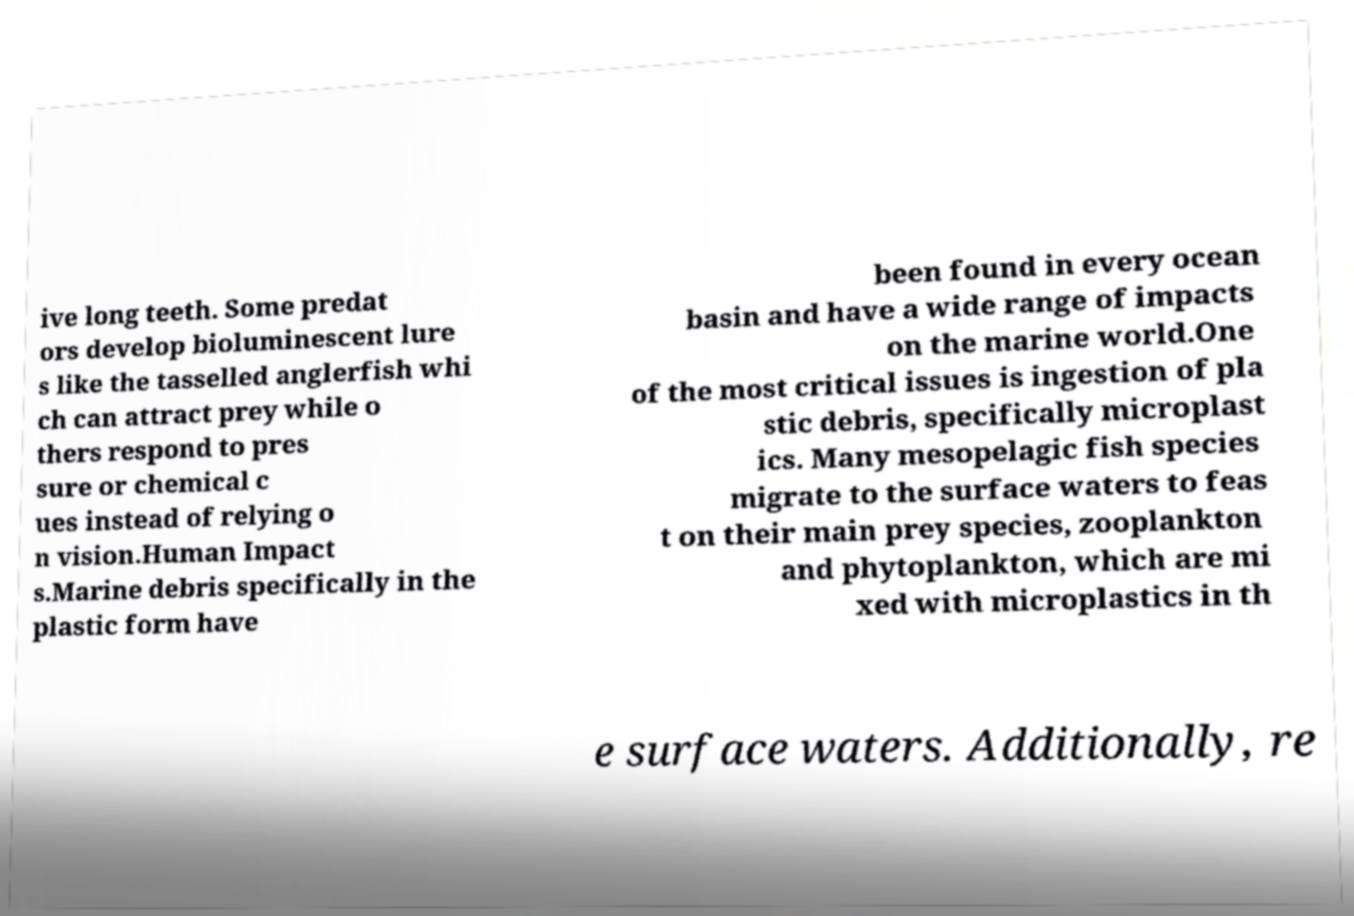For documentation purposes, I need the text within this image transcribed. Could you provide that? ive long teeth. Some predat ors develop bioluminescent lure s like the tasselled anglerfish whi ch can attract prey while o thers respond to pres sure or chemical c ues instead of relying o n vision.Human Impact s.Marine debris specifically in the plastic form have been found in every ocean basin and have a wide range of impacts on the marine world.One of the most critical issues is ingestion of pla stic debris, specifically microplast ics. Many mesopelagic fish species migrate to the surface waters to feas t on their main prey species, zooplankton and phytoplankton, which are mi xed with microplastics in th e surface waters. Additionally, re 